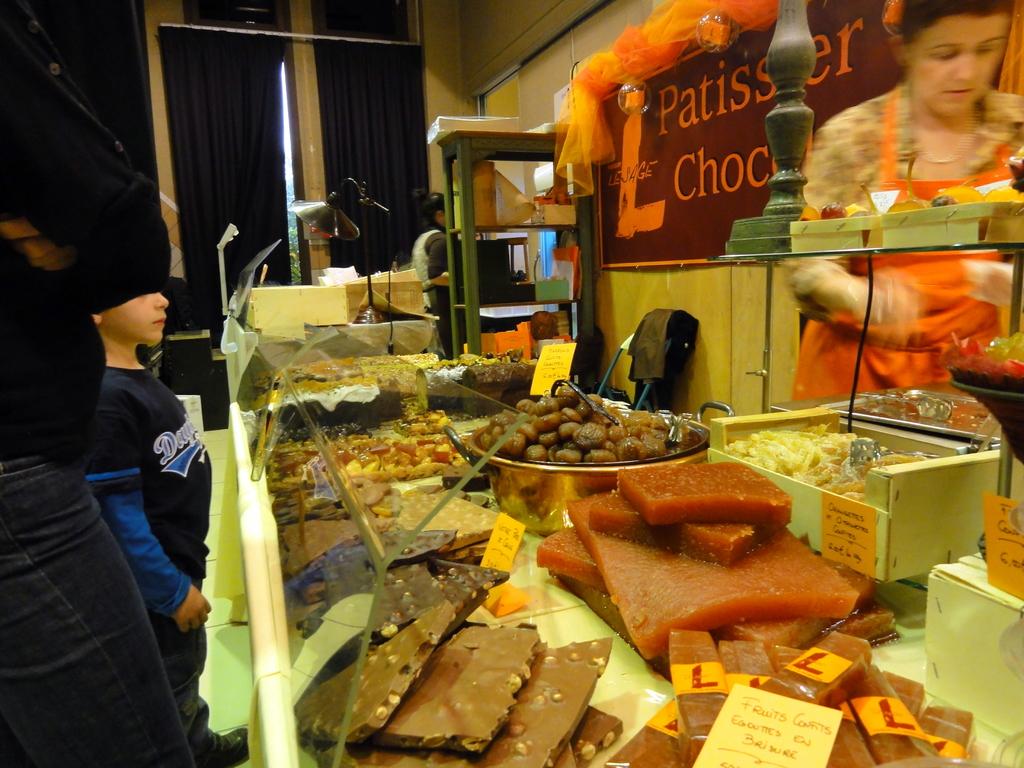What letter is in yellow?
Your answer should be compact. L. 